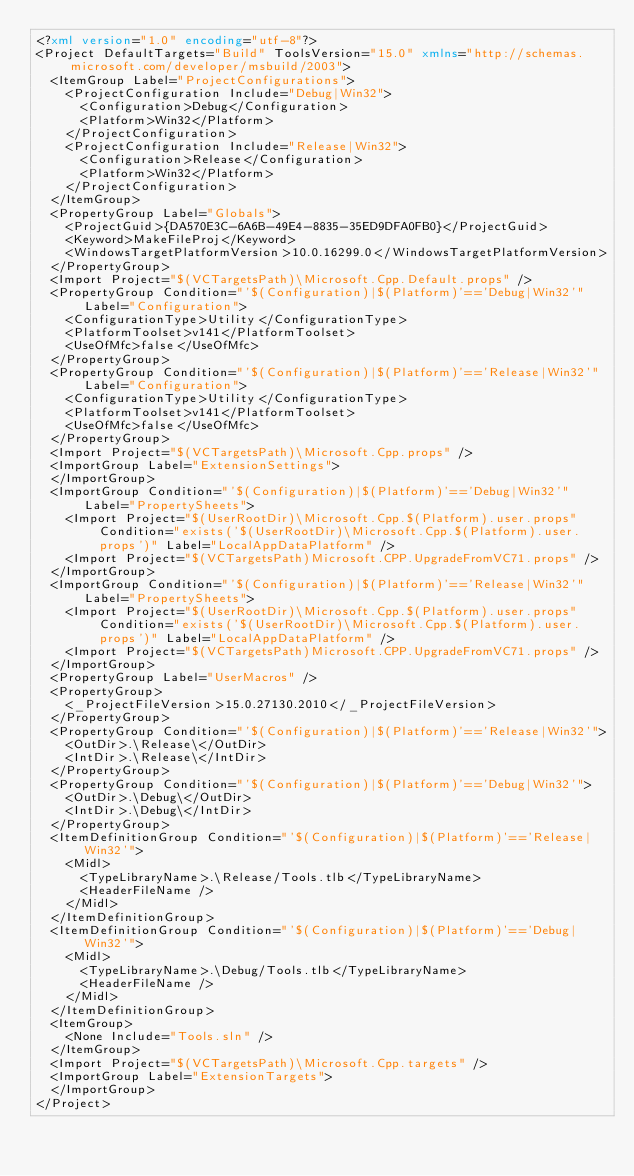Convert code to text. <code><loc_0><loc_0><loc_500><loc_500><_XML_><?xml version="1.0" encoding="utf-8"?>
<Project DefaultTargets="Build" ToolsVersion="15.0" xmlns="http://schemas.microsoft.com/developer/msbuild/2003">
  <ItemGroup Label="ProjectConfigurations">
    <ProjectConfiguration Include="Debug|Win32">
      <Configuration>Debug</Configuration>
      <Platform>Win32</Platform>
    </ProjectConfiguration>
    <ProjectConfiguration Include="Release|Win32">
      <Configuration>Release</Configuration>
      <Platform>Win32</Platform>
    </ProjectConfiguration>
  </ItemGroup>
  <PropertyGroup Label="Globals">
    <ProjectGuid>{DA570E3C-6A6B-49E4-8835-35ED9DFA0FB0}</ProjectGuid>
    <Keyword>MakeFileProj</Keyword>
    <WindowsTargetPlatformVersion>10.0.16299.0</WindowsTargetPlatformVersion>
  </PropertyGroup>
  <Import Project="$(VCTargetsPath)\Microsoft.Cpp.Default.props" />
  <PropertyGroup Condition="'$(Configuration)|$(Platform)'=='Debug|Win32'" Label="Configuration">
    <ConfigurationType>Utility</ConfigurationType>
    <PlatformToolset>v141</PlatformToolset>
    <UseOfMfc>false</UseOfMfc>
  </PropertyGroup>
  <PropertyGroup Condition="'$(Configuration)|$(Platform)'=='Release|Win32'" Label="Configuration">
    <ConfigurationType>Utility</ConfigurationType>
    <PlatformToolset>v141</PlatformToolset>
    <UseOfMfc>false</UseOfMfc>
  </PropertyGroup>
  <Import Project="$(VCTargetsPath)\Microsoft.Cpp.props" />
  <ImportGroup Label="ExtensionSettings">
  </ImportGroup>
  <ImportGroup Condition="'$(Configuration)|$(Platform)'=='Debug|Win32'" Label="PropertySheets">
    <Import Project="$(UserRootDir)\Microsoft.Cpp.$(Platform).user.props" Condition="exists('$(UserRootDir)\Microsoft.Cpp.$(Platform).user.props')" Label="LocalAppDataPlatform" />
    <Import Project="$(VCTargetsPath)Microsoft.CPP.UpgradeFromVC71.props" />
  </ImportGroup>
  <ImportGroup Condition="'$(Configuration)|$(Platform)'=='Release|Win32'" Label="PropertySheets">
    <Import Project="$(UserRootDir)\Microsoft.Cpp.$(Platform).user.props" Condition="exists('$(UserRootDir)\Microsoft.Cpp.$(Platform).user.props')" Label="LocalAppDataPlatform" />
    <Import Project="$(VCTargetsPath)Microsoft.CPP.UpgradeFromVC71.props" />
  </ImportGroup>
  <PropertyGroup Label="UserMacros" />
  <PropertyGroup>
    <_ProjectFileVersion>15.0.27130.2010</_ProjectFileVersion>
  </PropertyGroup>
  <PropertyGroup Condition="'$(Configuration)|$(Platform)'=='Release|Win32'">
    <OutDir>.\Release\</OutDir>
    <IntDir>.\Release\</IntDir>
  </PropertyGroup>
  <PropertyGroup Condition="'$(Configuration)|$(Platform)'=='Debug|Win32'">
    <OutDir>.\Debug\</OutDir>
    <IntDir>.\Debug\</IntDir>
  </PropertyGroup>
  <ItemDefinitionGroup Condition="'$(Configuration)|$(Platform)'=='Release|Win32'">
    <Midl>
      <TypeLibraryName>.\Release/Tools.tlb</TypeLibraryName>
      <HeaderFileName />
    </Midl>
  </ItemDefinitionGroup>
  <ItemDefinitionGroup Condition="'$(Configuration)|$(Platform)'=='Debug|Win32'">
    <Midl>
      <TypeLibraryName>.\Debug/Tools.tlb</TypeLibraryName>
      <HeaderFileName />
    </Midl>
  </ItemDefinitionGroup>
  <ItemGroup>
    <None Include="Tools.sln" />
  </ItemGroup>
  <Import Project="$(VCTargetsPath)\Microsoft.Cpp.targets" />
  <ImportGroup Label="ExtensionTargets">
  </ImportGroup>
</Project></code> 